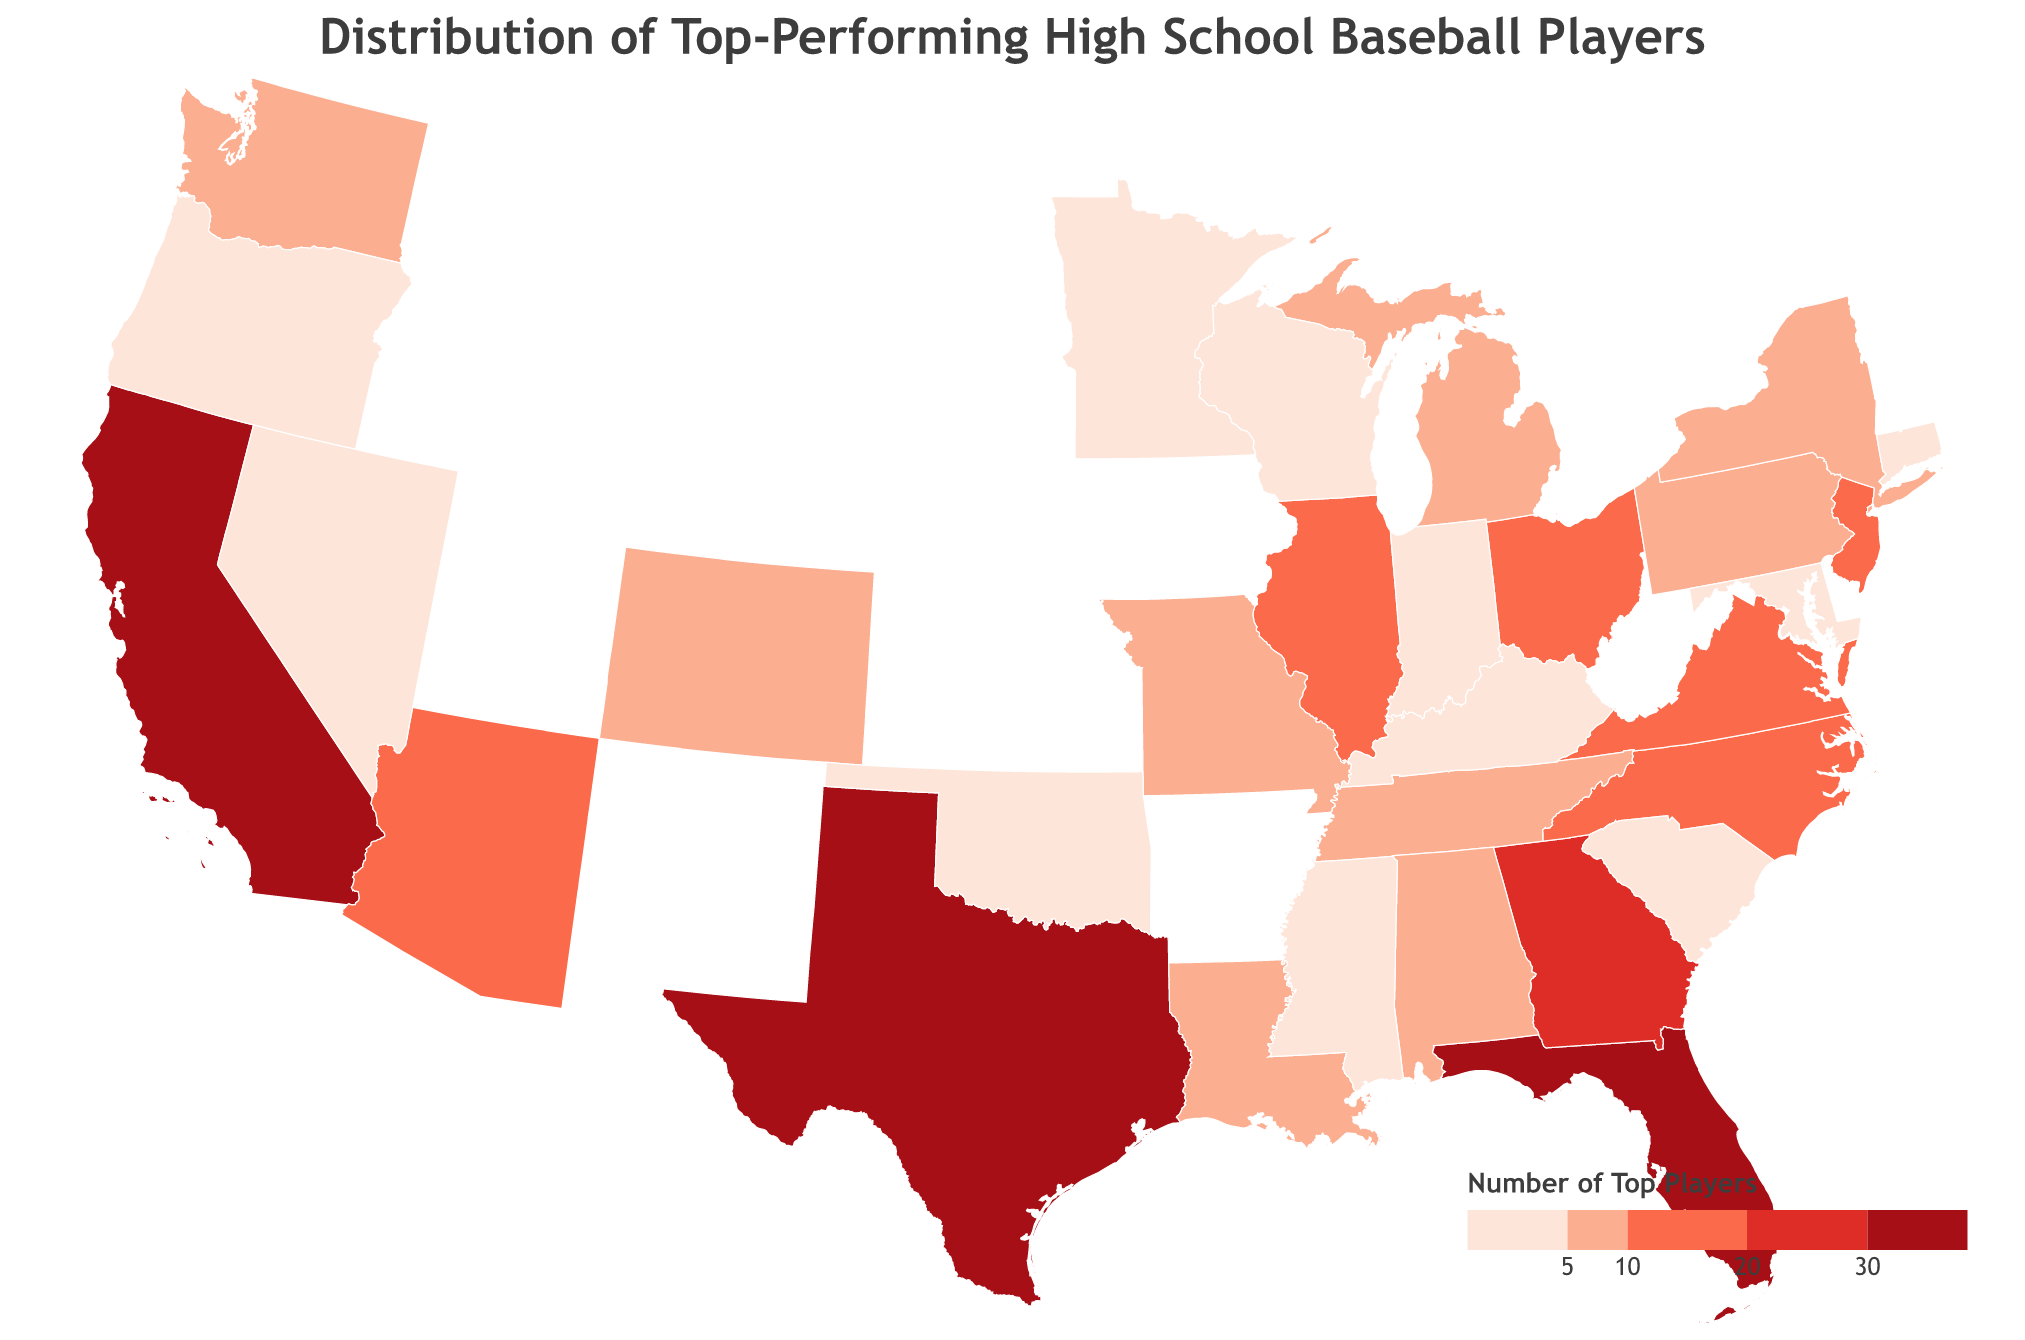How many states have more than 20 top-performing players? To determine this, look for states with more than 20 players on the plot. Count the states that meet this criterion. California, Florida, Texas, Georgia make 4 states.
Answer: 4 Which state has the highest number of top-performing high school baseball players? Look for the state with the darkest color on the plot, indicating the highest number of players. California has the highest number indicated by color.
Answer: California What is the total number of top-performing players from California, Florida, and Texas? Sum the number of players from these states: California (42), Florida (35), Texas (31). 42 + 35 + 31= 108
Answer: 108 Which state has the least number of top-performing high school baseball players? Look for the state with the lightest color on the plot among those listed. Minnesota and Kentucky both have 1 player.
Answer: Minnesota, Kentucky What is the median number of top-performing players from all the states? First, list all player numbers in ascending order: [1, 1, 2, 2, 2, 2, 3, 3, 3, 4, 4, 5, 5, 5, 5, 6, 7, 7, 8, 9, 10, 11, 12, 14, 16, 18, 25, 31, 35, 42]. The median is the middle value. There are 30 numbers, so the median is the average of the 15th and 16th numbers: (5 + 6) / 2 = 5.5
Answer: 5.5 Which region in the U.S. has the highest concentration of top-performing high school baseball players? Evaluate the color intensity across different regions: West (California), Southeast (Florida, Georgia), and Southeast has more high density states than any region.
Answer: Southeast How many states have exactly 5 top-performing high school baseball players? Identify states with 5 labeled on the plot: Alabama, Colorado, Michigan, New York. There are 4 states.
Answer: 4 Compare the number of top-performing players in Arizona and Illinois. Which state has more, and by how much? Compare the values: Arizona (16 players) and Illinois (14 players). Arizona has more by (16-14) = 2 players.
Answer: Arizona, 2 